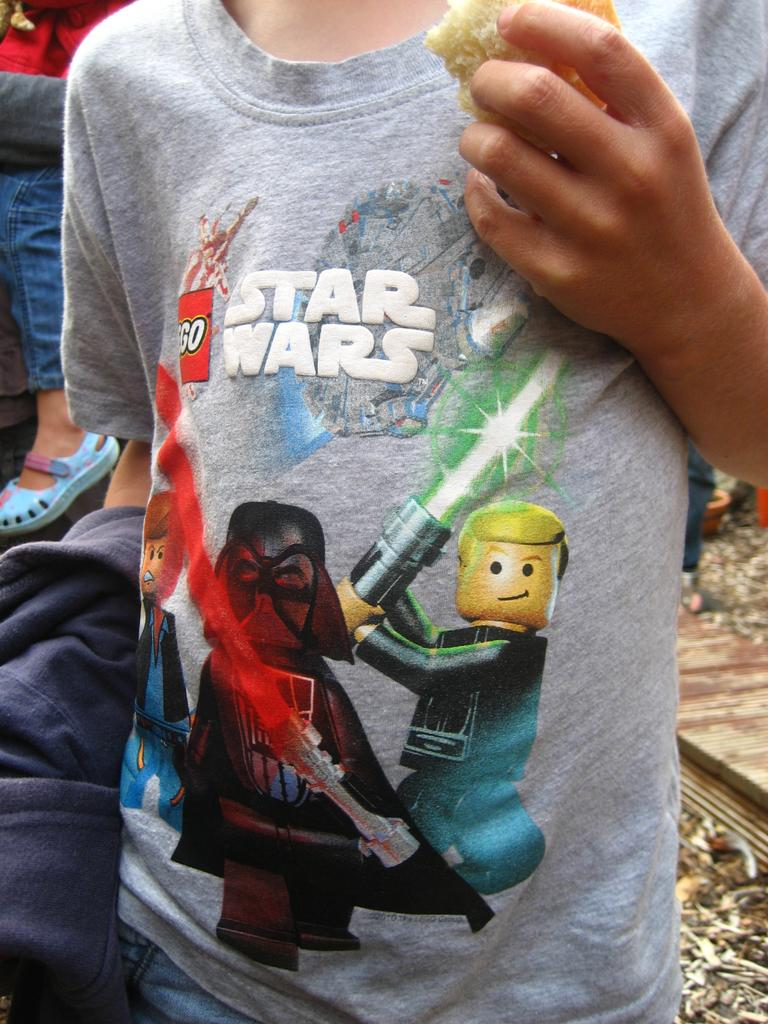What is the main subject of the image? The main subject of the image is a person standing. What is the person wearing in the image? The person is wearing a grey t-shirt. What design or pattern is on the t-shirt? The t-shirt has cartoon pictures of pictures on it. What type of butter is being used to draw the cartoon pictures on the t-shirt? There is no butter present in the image, and the cartoon pictures are not drawn on the t-shirt. 